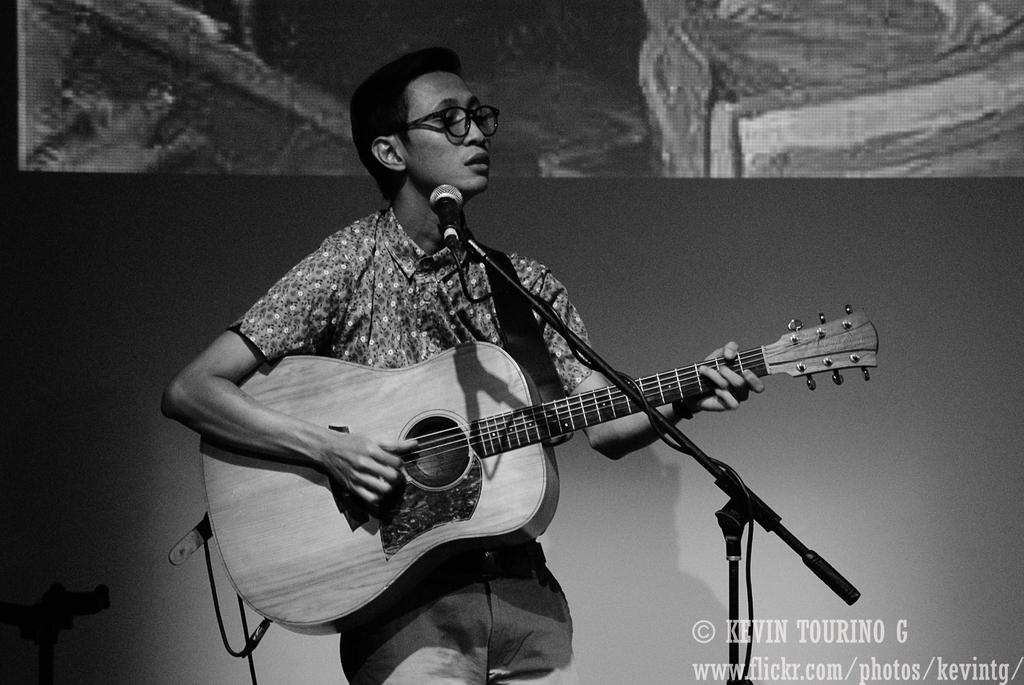What is the person in the image doing? The person is standing and holding a guitar. What object is present in the image that is commonly used for amplifying sound? There is a microphone in the image. What accessory can be seen on the person in the image? The person is wearing spectacles. Is there any indication of the image's origin or ownership? Yes, there is a watermark in the image. How many rabbits are hopping around the person in the image? There are no rabbits present in the image. What songs is the person singing in the image? The image does not provide any information about the songs being sung by the person. 